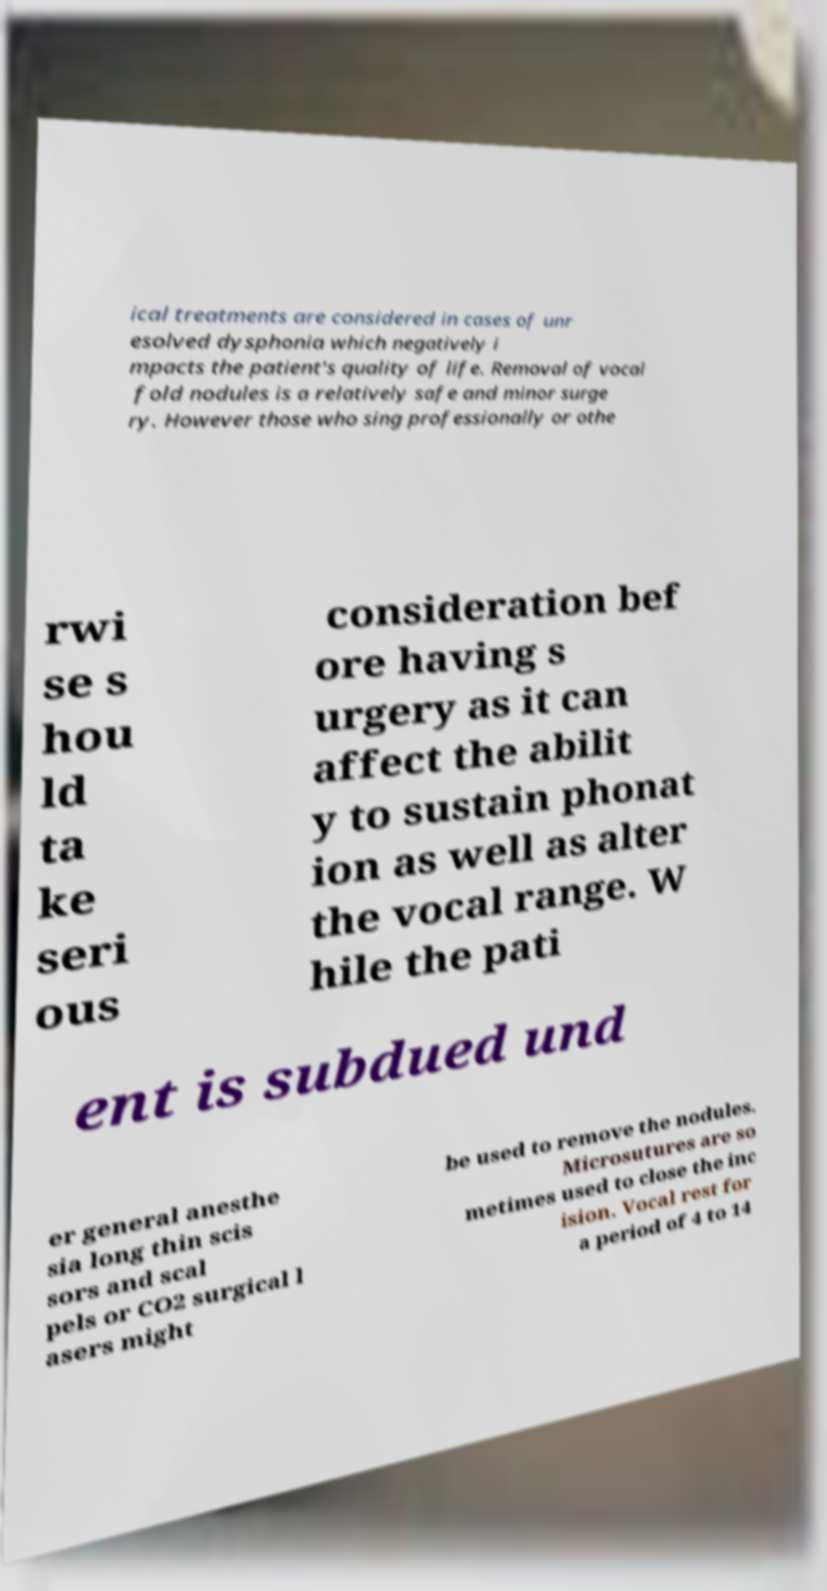Could you assist in decoding the text presented in this image and type it out clearly? ical treatments are considered in cases of unr esolved dysphonia which negatively i mpacts the patient's quality of life. Removal of vocal fold nodules is a relatively safe and minor surge ry. However those who sing professionally or othe rwi se s hou ld ta ke seri ous consideration bef ore having s urgery as it can affect the abilit y to sustain phonat ion as well as alter the vocal range. W hile the pati ent is subdued und er general anesthe sia long thin scis sors and scal pels or CO2 surgical l asers might be used to remove the nodules. Microsutures are so metimes used to close the inc ision. Vocal rest for a period of 4 to 14 